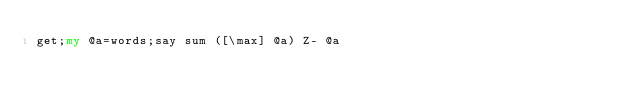Convert code to text. <code><loc_0><loc_0><loc_500><loc_500><_Perl_>get;my @a=words;say sum ([\max] @a) Z- @a</code> 